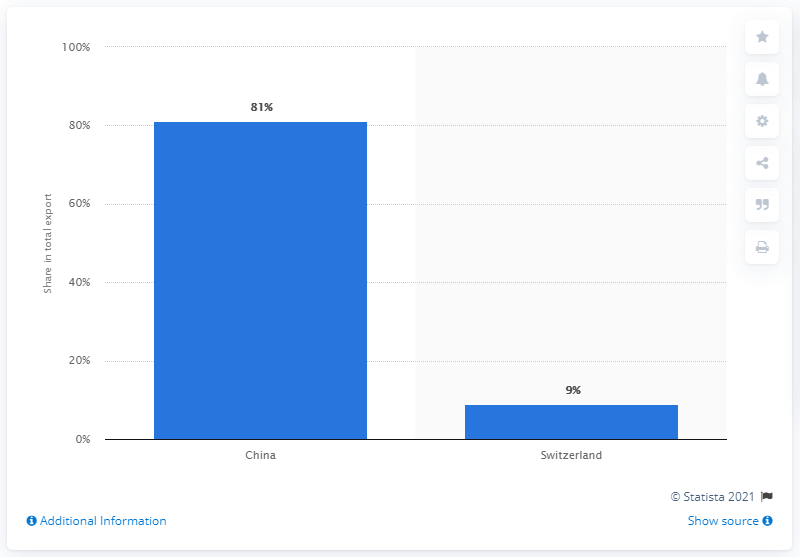Can you tell me what this chart is showing? This chart appears to be a bar graph illustrating the main export partners of Mongolia in a certain year, with China dominating as the principal export destination. Do you know what kinds of goods Mongolia exports to China? Mongolia exports various goods to China, including coal, copper, gold, textiles, and animal products such as cashmere. Mineral resources, particularly coal and copper, make up a substantial portion of these exports. 